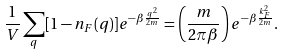Convert formula to latex. <formula><loc_0><loc_0><loc_500><loc_500>\frac { 1 } { V } \sum _ { q } [ 1 - n _ { F } ( { q } ) ] e ^ { - \beta \frac { q ^ { 2 } } { 2 m } } = \left ( \frac { m } { 2 \pi \beta } \right ) e ^ { - \beta \frac { k ^ { 2 } _ { F } } { 2 m } } .</formula> 